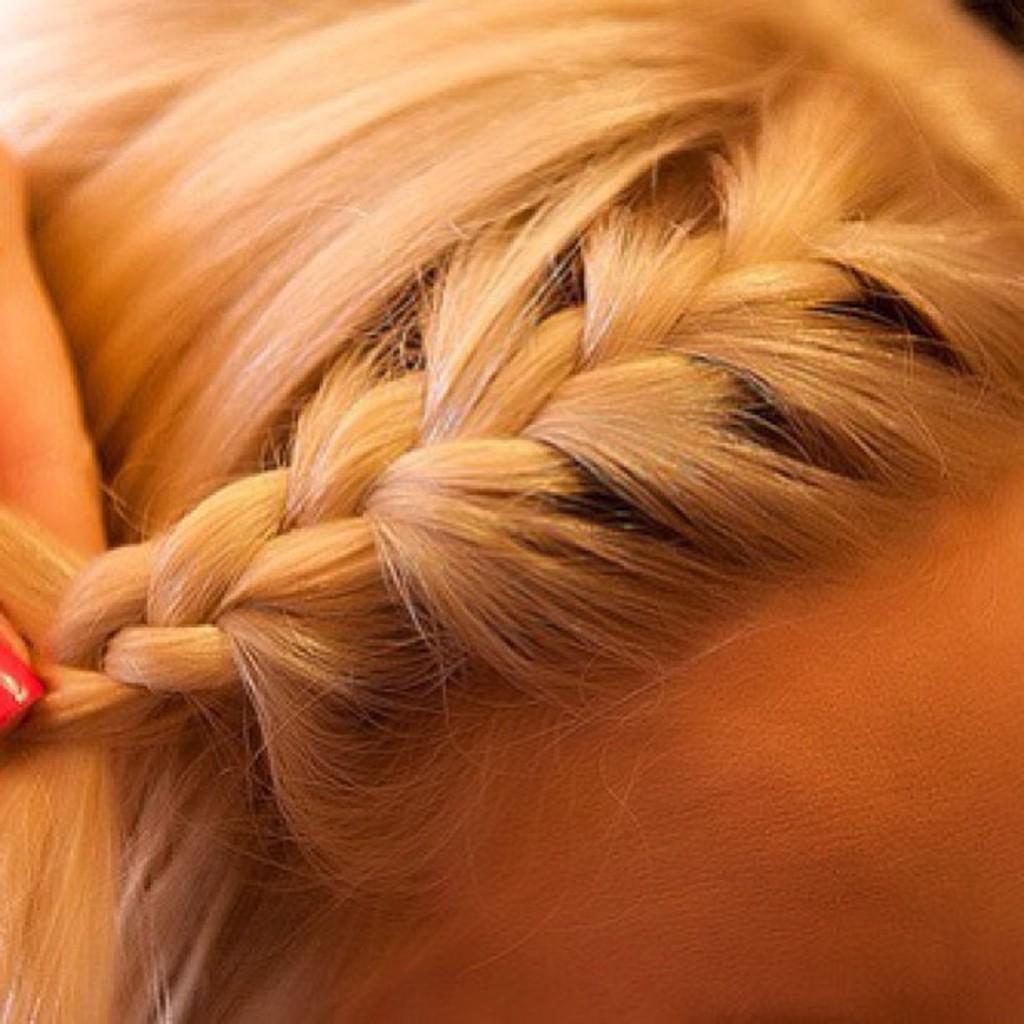What can be seen in the image related to a person? There is a person's hand in the image. What is the hand doing in the image? The hand is dressing a hairstyle. What type of sleet can be seen falling in the image? There is no sleet present in the image; it only features a person's hand dressing a hairstyle. 